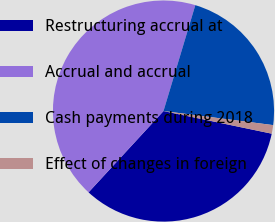<chart> <loc_0><loc_0><loc_500><loc_500><pie_chart><fcel>Restructuring accrual at<fcel>Accrual and accrual<fcel>Cash payments during 2018<fcel>Effect of changes in foreign<nl><fcel>33.57%<fcel>42.79%<fcel>22.38%<fcel>1.25%<nl></chart> 